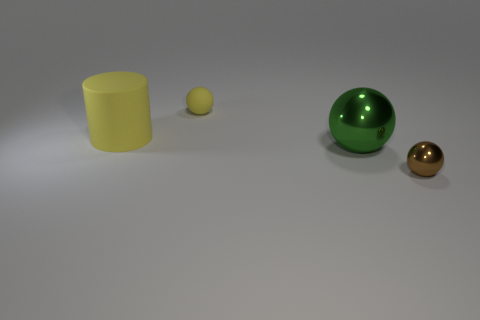There is a yellow object behind the cylinder; is its size the same as the brown shiny thing?
Offer a very short reply. Yes. There is a sphere that is behind the brown sphere and in front of the tiny yellow thing; what size is it?
Offer a very short reply. Large. What number of other objects are there of the same material as the large ball?
Make the answer very short. 1. What size is the yellow rubber thing that is right of the yellow cylinder?
Keep it short and to the point. Small. Do the large matte cylinder and the large metallic object have the same color?
Your answer should be compact. No. What number of big objects are yellow matte objects or yellow metallic objects?
Make the answer very short. 1. Is there any other thing that has the same color as the small shiny sphere?
Provide a succinct answer. No. There is a small yellow rubber sphere; are there any rubber spheres to the right of it?
Ensure brevity in your answer.  No. There is a metallic ball that is on the right side of the shiny object that is left of the tiny metallic thing; what is its size?
Offer a very short reply. Small. Are there an equal number of yellow rubber things that are in front of the tiny metallic thing and brown spheres in front of the yellow matte cylinder?
Make the answer very short. No. 